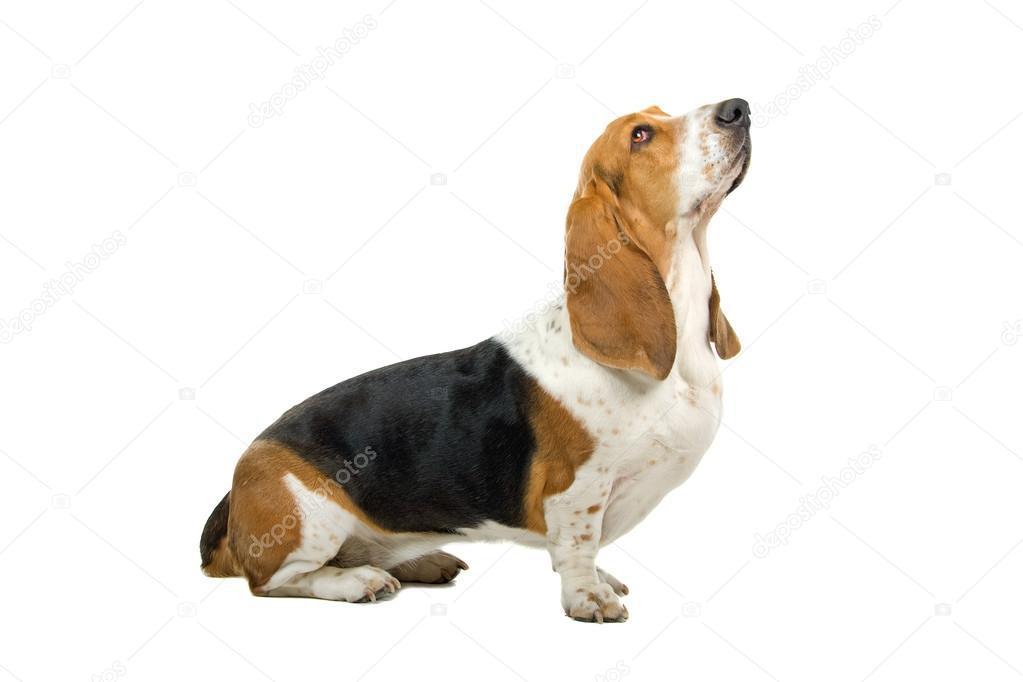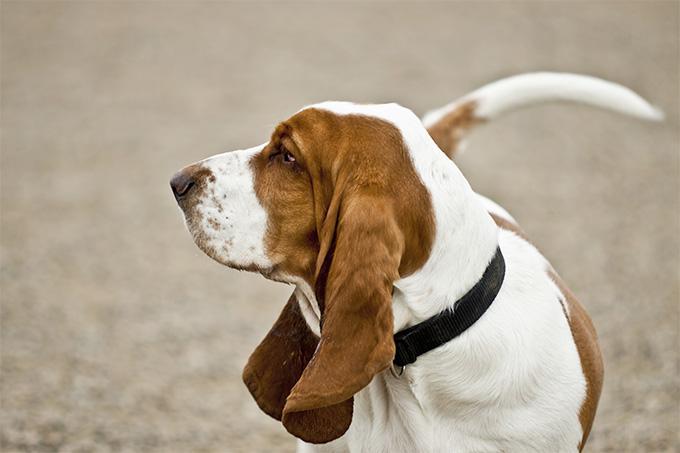The first image is the image on the left, the second image is the image on the right. Considering the images on both sides, is "An image shows one basset hound, which is looking up and toward the right." valid? Answer yes or no. Yes. The first image is the image on the left, the second image is the image on the right. Evaluate the accuracy of this statement regarding the images: "One basset hound is looking up with its nose pointed into the air.". Is it true? Answer yes or no. Yes. 